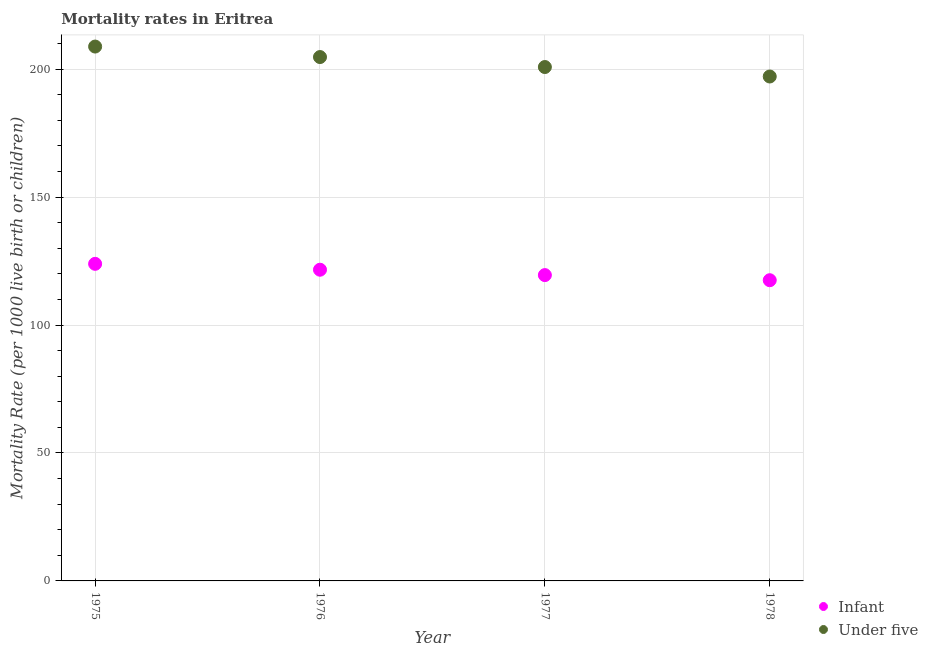Is the number of dotlines equal to the number of legend labels?
Ensure brevity in your answer.  Yes. What is the under-5 mortality rate in 1976?
Offer a very short reply. 204.7. Across all years, what is the maximum under-5 mortality rate?
Ensure brevity in your answer.  208.8. Across all years, what is the minimum under-5 mortality rate?
Offer a very short reply. 197.1. In which year was the under-5 mortality rate maximum?
Ensure brevity in your answer.  1975. In which year was the under-5 mortality rate minimum?
Your response must be concise. 1978. What is the total infant mortality rate in the graph?
Your response must be concise. 482.5. What is the difference between the under-5 mortality rate in 1978 and the infant mortality rate in 1977?
Provide a short and direct response. 77.6. What is the average infant mortality rate per year?
Provide a succinct answer. 120.62. In the year 1975, what is the difference between the infant mortality rate and under-5 mortality rate?
Provide a short and direct response. -84.9. In how many years, is the infant mortality rate greater than 120?
Offer a very short reply. 2. What is the ratio of the under-5 mortality rate in 1976 to that in 1977?
Ensure brevity in your answer.  1.02. What is the difference between the highest and the second highest infant mortality rate?
Your answer should be compact. 2.3. What is the difference between the highest and the lowest under-5 mortality rate?
Give a very brief answer. 11.7. Is the under-5 mortality rate strictly less than the infant mortality rate over the years?
Your answer should be compact. No. How many dotlines are there?
Make the answer very short. 2. What is the difference between two consecutive major ticks on the Y-axis?
Give a very brief answer. 50. Where does the legend appear in the graph?
Your answer should be very brief. Bottom right. How many legend labels are there?
Your response must be concise. 2. How are the legend labels stacked?
Provide a succinct answer. Vertical. What is the title of the graph?
Your answer should be very brief. Mortality rates in Eritrea. Does "DAC donors" appear as one of the legend labels in the graph?
Give a very brief answer. No. What is the label or title of the Y-axis?
Your answer should be compact. Mortality Rate (per 1000 live birth or children). What is the Mortality Rate (per 1000 live birth or children) in Infant in 1975?
Offer a very short reply. 123.9. What is the Mortality Rate (per 1000 live birth or children) in Under five in 1975?
Offer a terse response. 208.8. What is the Mortality Rate (per 1000 live birth or children) of Infant in 1976?
Keep it short and to the point. 121.6. What is the Mortality Rate (per 1000 live birth or children) in Under five in 1976?
Offer a terse response. 204.7. What is the Mortality Rate (per 1000 live birth or children) of Infant in 1977?
Provide a succinct answer. 119.5. What is the Mortality Rate (per 1000 live birth or children) in Under five in 1977?
Make the answer very short. 200.8. What is the Mortality Rate (per 1000 live birth or children) in Infant in 1978?
Provide a short and direct response. 117.5. What is the Mortality Rate (per 1000 live birth or children) of Under five in 1978?
Ensure brevity in your answer.  197.1. Across all years, what is the maximum Mortality Rate (per 1000 live birth or children) in Infant?
Provide a succinct answer. 123.9. Across all years, what is the maximum Mortality Rate (per 1000 live birth or children) of Under five?
Give a very brief answer. 208.8. Across all years, what is the minimum Mortality Rate (per 1000 live birth or children) of Infant?
Your response must be concise. 117.5. Across all years, what is the minimum Mortality Rate (per 1000 live birth or children) in Under five?
Offer a very short reply. 197.1. What is the total Mortality Rate (per 1000 live birth or children) in Infant in the graph?
Give a very brief answer. 482.5. What is the total Mortality Rate (per 1000 live birth or children) of Under five in the graph?
Provide a succinct answer. 811.4. What is the difference between the Mortality Rate (per 1000 live birth or children) of Under five in 1975 and that in 1976?
Provide a short and direct response. 4.1. What is the difference between the Mortality Rate (per 1000 live birth or children) of Infant in 1975 and that in 1977?
Offer a very short reply. 4.4. What is the difference between the Mortality Rate (per 1000 live birth or children) in Under five in 1975 and that in 1978?
Give a very brief answer. 11.7. What is the difference between the Mortality Rate (per 1000 live birth or children) of Under five in 1976 and that in 1978?
Ensure brevity in your answer.  7.6. What is the difference between the Mortality Rate (per 1000 live birth or children) in Infant in 1975 and the Mortality Rate (per 1000 live birth or children) in Under five in 1976?
Make the answer very short. -80.8. What is the difference between the Mortality Rate (per 1000 live birth or children) in Infant in 1975 and the Mortality Rate (per 1000 live birth or children) in Under five in 1977?
Offer a terse response. -76.9. What is the difference between the Mortality Rate (per 1000 live birth or children) of Infant in 1975 and the Mortality Rate (per 1000 live birth or children) of Under five in 1978?
Give a very brief answer. -73.2. What is the difference between the Mortality Rate (per 1000 live birth or children) in Infant in 1976 and the Mortality Rate (per 1000 live birth or children) in Under five in 1977?
Provide a succinct answer. -79.2. What is the difference between the Mortality Rate (per 1000 live birth or children) of Infant in 1976 and the Mortality Rate (per 1000 live birth or children) of Under five in 1978?
Your response must be concise. -75.5. What is the difference between the Mortality Rate (per 1000 live birth or children) in Infant in 1977 and the Mortality Rate (per 1000 live birth or children) in Under five in 1978?
Your answer should be compact. -77.6. What is the average Mortality Rate (per 1000 live birth or children) of Infant per year?
Your answer should be very brief. 120.62. What is the average Mortality Rate (per 1000 live birth or children) in Under five per year?
Offer a very short reply. 202.85. In the year 1975, what is the difference between the Mortality Rate (per 1000 live birth or children) of Infant and Mortality Rate (per 1000 live birth or children) of Under five?
Offer a very short reply. -84.9. In the year 1976, what is the difference between the Mortality Rate (per 1000 live birth or children) of Infant and Mortality Rate (per 1000 live birth or children) of Under five?
Your answer should be compact. -83.1. In the year 1977, what is the difference between the Mortality Rate (per 1000 live birth or children) of Infant and Mortality Rate (per 1000 live birth or children) of Under five?
Make the answer very short. -81.3. In the year 1978, what is the difference between the Mortality Rate (per 1000 live birth or children) of Infant and Mortality Rate (per 1000 live birth or children) of Under five?
Provide a succinct answer. -79.6. What is the ratio of the Mortality Rate (per 1000 live birth or children) in Infant in 1975 to that in 1976?
Offer a very short reply. 1.02. What is the ratio of the Mortality Rate (per 1000 live birth or children) of Infant in 1975 to that in 1977?
Your answer should be very brief. 1.04. What is the ratio of the Mortality Rate (per 1000 live birth or children) in Under five in 1975 to that in 1977?
Offer a very short reply. 1.04. What is the ratio of the Mortality Rate (per 1000 live birth or children) in Infant in 1975 to that in 1978?
Make the answer very short. 1.05. What is the ratio of the Mortality Rate (per 1000 live birth or children) in Under five in 1975 to that in 1978?
Make the answer very short. 1.06. What is the ratio of the Mortality Rate (per 1000 live birth or children) of Infant in 1976 to that in 1977?
Make the answer very short. 1.02. What is the ratio of the Mortality Rate (per 1000 live birth or children) in Under five in 1976 to that in 1977?
Offer a very short reply. 1.02. What is the ratio of the Mortality Rate (per 1000 live birth or children) in Infant in 1976 to that in 1978?
Offer a terse response. 1.03. What is the ratio of the Mortality Rate (per 1000 live birth or children) in Under five in 1976 to that in 1978?
Your answer should be compact. 1.04. What is the ratio of the Mortality Rate (per 1000 live birth or children) in Under five in 1977 to that in 1978?
Give a very brief answer. 1.02. What is the difference between the highest and the second highest Mortality Rate (per 1000 live birth or children) in Infant?
Ensure brevity in your answer.  2.3. What is the difference between the highest and the second highest Mortality Rate (per 1000 live birth or children) in Under five?
Provide a succinct answer. 4.1. 